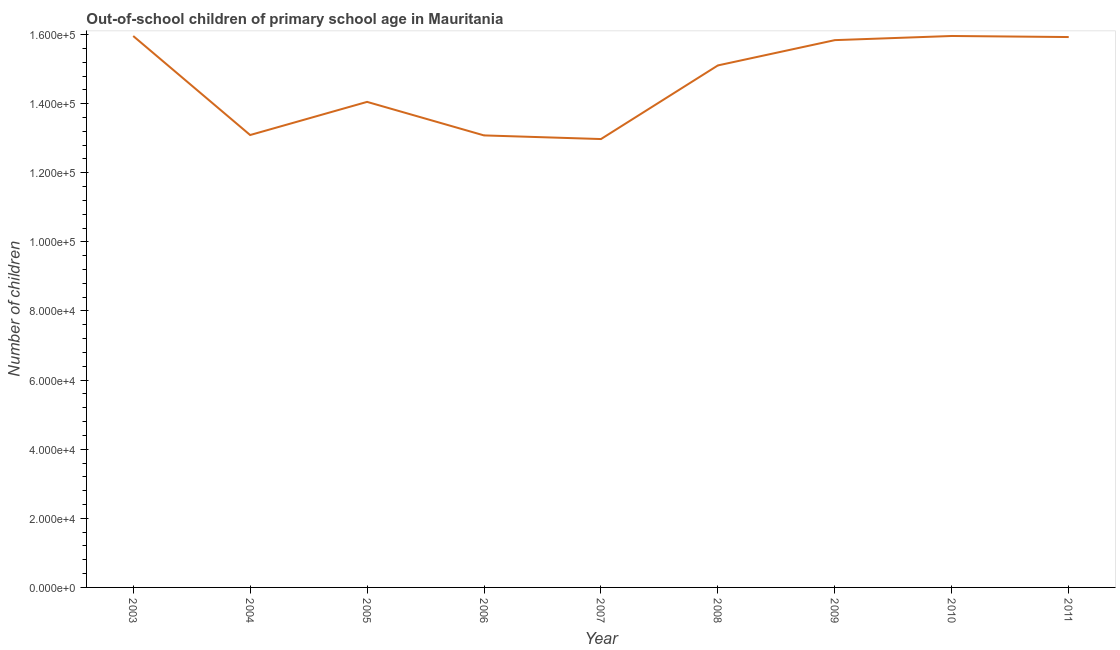What is the number of out-of-school children in 2004?
Your response must be concise. 1.31e+05. Across all years, what is the maximum number of out-of-school children?
Give a very brief answer. 1.60e+05. Across all years, what is the minimum number of out-of-school children?
Ensure brevity in your answer.  1.30e+05. In which year was the number of out-of-school children minimum?
Offer a very short reply. 2007. What is the sum of the number of out-of-school children?
Offer a very short reply. 1.32e+06. What is the difference between the number of out-of-school children in 2003 and 2008?
Offer a terse response. 8507. What is the average number of out-of-school children per year?
Give a very brief answer. 1.47e+05. What is the median number of out-of-school children?
Ensure brevity in your answer.  1.51e+05. In how many years, is the number of out-of-school children greater than 128000 ?
Give a very brief answer. 9. Do a majority of the years between 2006 and 2003 (inclusive) have number of out-of-school children greater than 156000 ?
Ensure brevity in your answer.  Yes. What is the ratio of the number of out-of-school children in 2003 to that in 2010?
Make the answer very short. 1. What is the difference between the highest and the lowest number of out-of-school children?
Give a very brief answer. 2.98e+04. In how many years, is the number of out-of-school children greater than the average number of out-of-school children taken over all years?
Your answer should be compact. 5. Does the number of out-of-school children monotonically increase over the years?
Your answer should be compact. No. What is the difference between two consecutive major ticks on the Y-axis?
Your answer should be compact. 2.00e+04. Are the values on the major ticks of Y-axis written in scientific E-notation?
Ensure brevity in your answer.  Yes. What is the title of the graph?
Provide a short and direct response. Out-of-school children of primary school age in Mauritania. What is the label or title of the X-axis?
Ensure brevity in your answer.  Year. What is the label or title of the Y-axis?
Provide a short and direct response. Number of children. What is the Number of children of 2003?
Your answer should be very brief. 1.60e+05. What is the Number of children in 2004?
Offer a very short reply. 1.31e+05. What is the Number of children of 2005?
Offer a very short reply. 1.41e+05. What is the Number of children in 2006?
Keep it short and to the point. 1.31e+05. What is the Number of children in 2007?
Ensure brevity in your answer.  1.30e+05. What is the Number of children of 2008?
Provide a short and direct response. 1.51e+05. What is the Number of children of 2009?
Your answer should be very brief. 1.58e+05. What is the Number of children in 2010?
Keep it short and to the point. 1.60e+05. What is the Number of children of 2011?
Make the answer very short. 1.59e+05. What is the difference between the Number of children in 2003 and 2004?
Provide a succinct answer. 2.87e+04. What is the difference between the Number of children in 2003 and 2005?
Keep it short and to the point. 1.91e+04. What is the difference between the Number of children in 2003 and 2006?
Ensure brevity in your answer.  2.88e+04. What is the difference between the Number of children in 2003 and 2007?
Keep it short and to the point. 2.98e+04. What is the difference between the Number of children in 2003 and 2008?
Provide a succinct answer. 8507. What is the difference between the Number of children in 2003 and 2009?
Give a very brief answer. 1192. What is the difference between the Number of children in 2003 and 2011?
Your answer should be compact. 299. What is the difference between the Number of children in 2004 and 2005?
Your answer should be very brief. -9594. What is the difference between the Number of children in 2004 and 2006?
Your answer should be very brief. 110. What is the difference between the Number of children in 2004 and 2007?
Ensure brevity in your answer.  1165. What is the difference between the Number of children in 2004 and 2008?
Give a very brief answer. -2.01e+04. What is the difference between the Number of children in 2004 and 2009?
Your response must be concise. -2.75e+04. What is the difference between the Number of children in 2004 and 2010?
Your answer should be very brief. -2.87e+04. What is the difference between the Number of children in 2004 and 2011?
Offer a terse response. -2.84e+04. What is the difference between the Number of children in 2005 and 2006?
Make the answer very short. 9704. What is the difference between the Number of children in 2005 and 2007?
Give a very brief answer. 1.08e+04. What is the difference between the Number of children in 2005 and 2008?
Make the answer very short. -1.06e+04. What is the difference between the Number of children in 2005 and 2009?
Make the answer very short. -1.79e+04. What is the difference between the Number of children in 2005 and 2010?
Your answer should be compact. -1.91e+04. What is the difference between the Number of children in 2005 and 2011?
Keep it short and to the point. -1.88e+04. What is the difference between the Number of children in 2006 and 2007?
Provide a succinct answer. 1055. What is the difference between the Number of children in 2006 and 2008?
Offer a very short reply. -2.03e+04. What is the difference between the Number of children in 2006 and 2009?
Provide a short and direct response. -2.76e+04. What is the difference between the Number of children in 2006 and 2010?
Give a very brief answer. -2.88e+04. What is the difference between the Number of children in 2006 and 2011?
Offer a very short reply. -2.85e+04. What is the difference between the Number of children in 2007 and 2008?
Make the answer very short. -2.13e+04. What is the difference between the Number of children in 2007 and 2009?
Your response must be concise. -2.86e+04. What is the difference between the Number of children in 2007 and 2010?
Your answer should be very brief. -2.98e+04. What is the difference between the Number of children in 2007 and 2011?
Offer a terse response. -2.95e+04. What is the difference between the Number of children in 2008 and 2009?
Provide a short and direct response. -7315. What is the difference between the Number of children in 2008 and 2010?
Offer a very short reply. -8517. What is the difference between the Number of children in 2008 and 2011?
Keep it short and to the point. -8208. What is the difference between the Number of children in 2009 and 2010?
Your response must be concise. -1202. What is the difference between the Number of children in 2009 and 2011?
Your answer should be compact. -893. What is the difference between the Number of children in 2010 and 2011?
Offer a terse response. 309. What is the ratio of the Number of children in 2003 to that in 2004?
Provide a succinct answer. 1.22. What is the ratio of the Number of children in 2003 to that in 2005?
Offer a terse response. 1.14. What is the ratio of the Number of children in 2003 to that in 2006?
Give a very brief answer. 1.22. What is the ratio of the Number of children in 2003 to that in 2007?
Provide a short and direct response. 1.23. What is the ratio of the Number of children in 2003 to that in 2008?
Provide a succinct answer. 1.06. What is the ratio of the Number of children in 2003 to that in 2010?
Provide a short and direct response. 1. What is the ratio of the Number of children in 2003 to that in 2011?
Provide a succinct answer. 1. What is the ratio of the Number of children in 2004 to that in 2005?
Make the answer very short. 0.93. What is the ratio of the Number of children in 2004 to that in 2008?
Your answer should be compact. 0.87. What is the ratio of the Number of children in 2004 to that in 2009?
Provide a short and direct response. 0.83. What is the ratio of the Number of children in 2004 to that in 2010?
Make the answer very short. 0.82. What is the ratio of the Number of children in 2004 to that in 2011?
Your response must be concise. 0.82. What is the ratio of the Number of children in 2005 to that in 2006?
Provide a short and direct response. 1.07. What is the ratio of the Number of children in 2005 to that in 2007?
Give a very brief answer. 1.08. What is the ratio of the Number of children in 2005 to that in 2009?
Offer a very short reply. 0.89. What is the ratio of the Number of children in 2005 to that in 2010?
Provide a short and direct response. 0.88. What is the ratio of the Number of children in 2005 to that in 2011?
Your answer should be compact. 0.88. What is the ratio of the Number of children in 2006 to that in 2008?
Ensure brevity in your answer.  0.87. What is the ratio of the Number of children in 2006 to that in 2009?
Provide a succinct answer. 0.83. What is the ratio of the Number of children in 2006 to that in 2010?
Your answer should be very brief. 0.82. What is the ratio of the Number of children in 2006 to that in 2011?
Keep it short and to the point. 0.82. What is the ratio of the Number of children in 2007 to that in 2008?
Offer a terse response. 0.86. What is the ratio of the Number of children in 2007 to that in 2009?
Ensure brevity in your answer.  0.82. What is the ratio of the Number of children in 2007 to that in 2010?
Your answer should be very brief. 0.81. What is the ratio of the Number of children in 2007 to that in 2011?
Offer a terse response. 0.81. What is the ratio of the Number of children in 2008 to that in 2009?
Offer a very short reply. 0.95. What is the ratio of the Number of children in 2008 to that in 2010?
Keep it short and to the point. 0.95. What is the ratio of the Number of children in 2008 to that in 2011?
Your response must be concise. 0.95. What is the ratio of the Number of children in 2010 to that in 2011?
Your response must be concise. 1. 